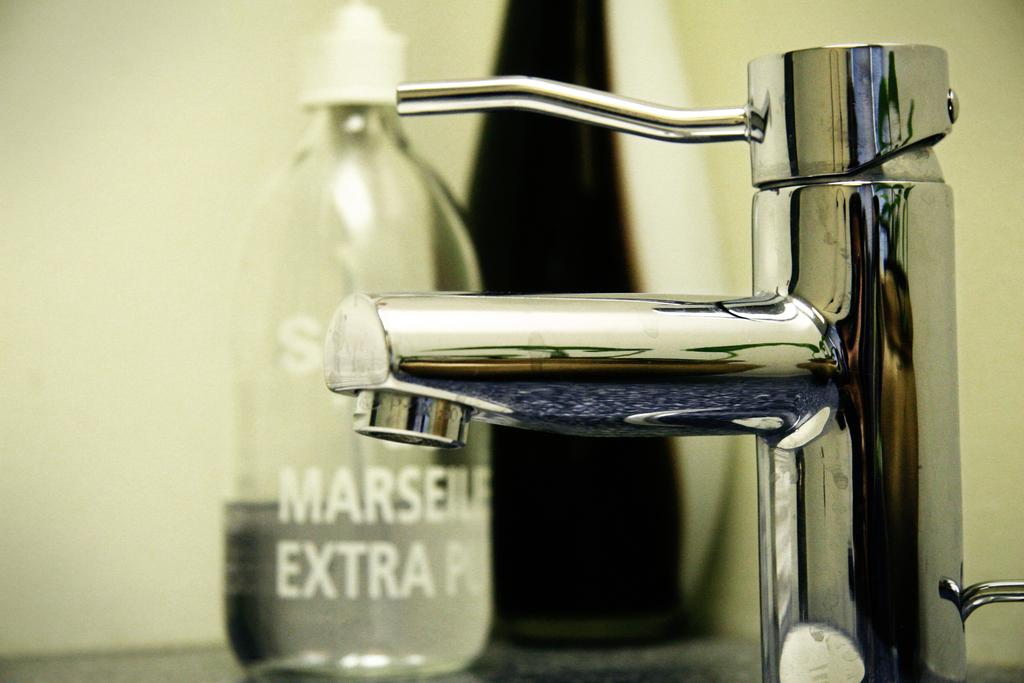<image>
Present a compact description of the photo's key features. Sink near a bottle that has the word EXTRA on it. 